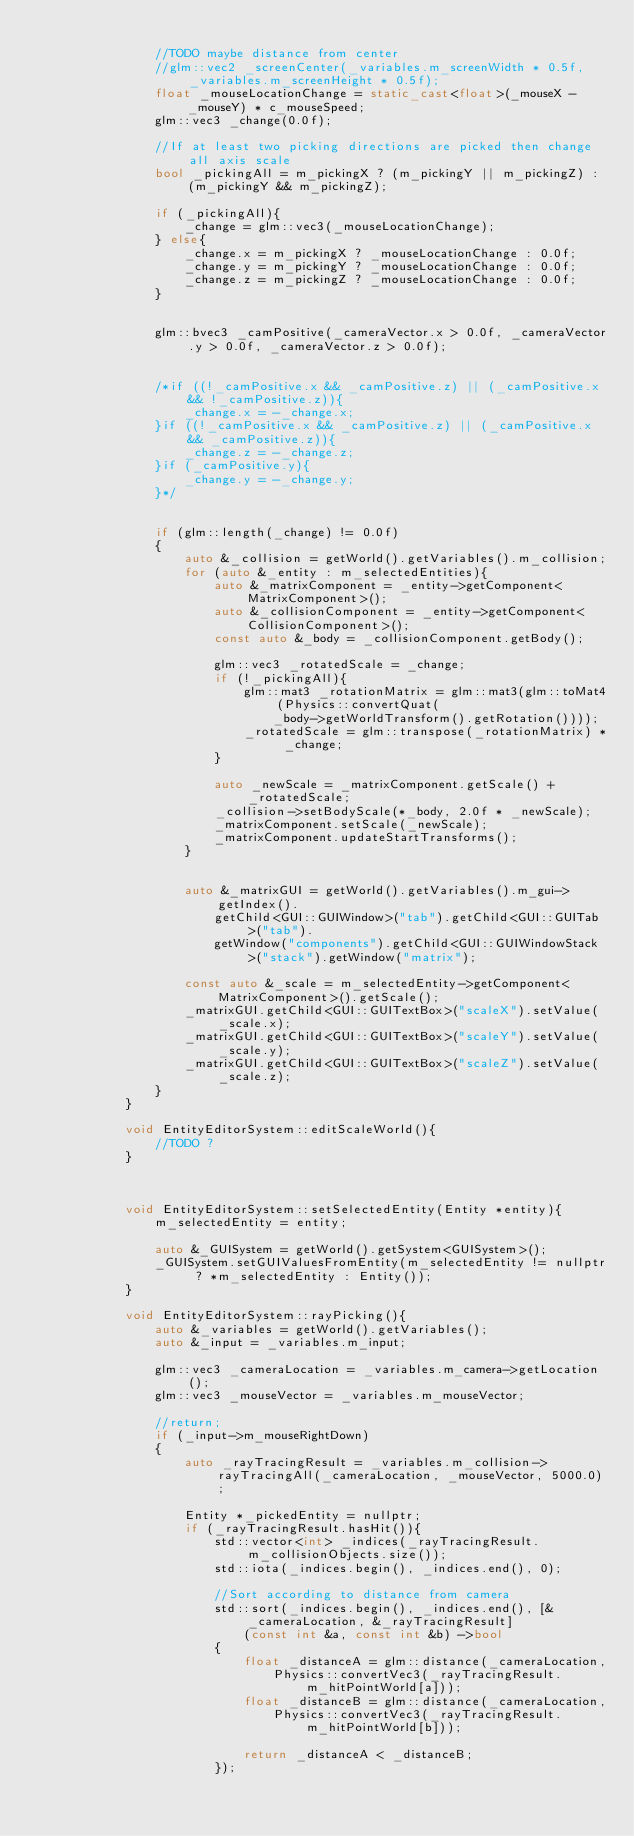<code> <loc_0><loc_0><loc_500><loc_500><_C++_>
				//TODO maybe distance from center
				//glm::vec2 _screenCenter(_variables.m_screenWidth * 0.5f, _variables.m_screenHeight * 0.5f);		
				float _mouseLocationChange = static_cast<float>(_mouseX - _mouseY) * c_mouseSpeed;
				glm::vec3 _change(0.0f);
				
				//If at least two picking directions are picked then change all axis scale
				bool _pickingAll = m_pickingX ? (m_pickingY || m_pickingZ) : (m_pickingY && m_pickingZ);

				if (_pickingAll){
					_change = glm::vec3(_mouseLocationChange);
				} else{
					_change.x = m_pickingX ? _mouseLocationChange : 0.0f;
					_change.y = m_pickingY ? _mouseLocationChange : 0.0f;
					_change.z = m_pickingZ ? _mouseLocationChange : 0.0f;
				}

				
				glm::bvec3 _camPositive(_cameraVector.x > 0.0f, _cameraVector.y > 0.0f, _cameraVector.z > 0.0f);	


				/*if ((!_camPositive.x && _camPositive.z) || (_camPositive.x && !_camPositive.z)){
					_change.x = -_change.x;
				}if ((!_camPositive.x && _camPositive.z) || (_camPositive.x && _camPositive.z)){
					_change.z = -_change.z;
				}if (_camPositive.y){
					_change.y = -_change.y;
				}*/


				if (glm::length(_change) != 0.0f)
				{
					auto &_collision = getWorld().getVariables().m_collision;
					for (auto &_entity : m_selectedEntities){
						auto &_matrixComponent = _entity->getComponent<MatrixComponent>();
						auto &_collisionComponent = _entity->getComponent<CollisionComponent>();
						const auto &_body = _collisionComponent.getBody();

						glm::vec3 _rotatedScale = _change;
						if (!_pickingAll){
							glm::mat3 _rotationMatrix = glm::mat3(glm::toMat4(Physics::convertQuat(
								_body->getWorldTransform().getRotation())));
							_rotatedScale = glm::transpose(_rotationMatrix) * _change;
						}

						auto _newScale = _matrixComponent.getScale() + _rotatedScale;
						_collision->setBodyScale(*_body, 2.0f * _newScale);
						_matrixComponent.setScale(_newScale);
						_matrixComponent.updateStartTransforms();
					}

		
					auto &_matrixGUI = getWorld().getVariables().m_gui->getIndex().
						getChild<GUI::GUIWindow>("tab").getChild<GUI::GUITab>("tab").
						getWindow("components").getChild<GUI::GUIWindowStack>("stack").getWindow("matrix");

					const auto &_scale = m_selectedEntity->getComponent<MatrixComponent>().getScale();
					_matrixGUI.getChild<GUI::GUITextBox>("scaleX").setValue(_scale.x);
					_matrixGUI.getChild<GUI::GUITextBox>("scaleY").setValue(_scale.y);
					_matrixGUI.getChild<GUI::GUITextBox>("scaleZ").setValue(_scale.z);		
				}	
			}

			void EntityEditorSystem::editScaleWorld(){
				//TODO ?
			}



			void EntityEditorSystem::setSelectedEntity(Entity *entity){
				m_selectedEntity = entity;
					
				auto &_GUISystem = getWorld().getSystem<GUISystem>();
				_GUISystem.setGUIValuesFromEntity(m_selectedEntity != nullptr ? *m_selectedEntity : Entity());
			}
		
			void EntityEditorSystem::rayPicking(){
				auto &_variables = getWorld().getVariables();
				auto &_input = _variables.m_input;

				glm::vec3 _cameraLocation = _variables.m_camera->getLocation();
				glm::vec3 _mouseVector = _variables.m_mouseVector;

				//return;
				if (_input->m_mouseRightDown)
				{
					auto _rayTracingResult = _variables.m_collision->rayTracingAll(_cameraLocation, _mouseVector, 5000.0);

					Entity *_pickedEntity = nullptr;
					if (_rayTracingResult.hasHit()){
						std::vector<int> _indices(_rayTracingResult.m_collisionObjects.size());
						std::iota(_indices.begin(), _indices.end(), 0);

						//Sort according to distance from camera
						std::sort(_indices.begin(), _indices.end(), [&_cameraLocation, &_rayTracingResult]
							(const int &a, const int &b) ->bool
						{
							float _distanceA = glm::distance(_cameraLocation,
								Physics::convertVec3(_rayTracingResult.m_hitPointWorld[a]));
							float _distanceB = glm::distance(_cameraLocation,
								Physics::convertVec3(_rayTracingResult.m_hitPointWorld[b]));

							return _distanceA < _distanceB;
						});

</code> 